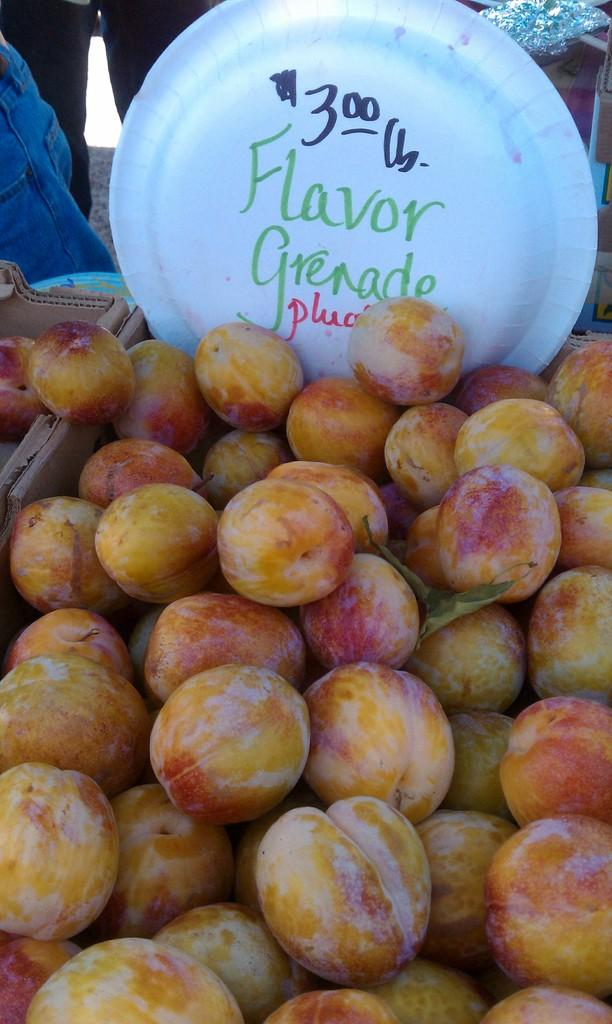What is inside the boxes in the image? There are fruits in the boxes. What is on the white plate in the image? There is a white color plate with text on it. Can you describe anything about the person in the image? Legs of a person are visible in the background of the image. What type of payment is being made by the governor in the image? There is no governor or payment present in the image. What role does the porter play in the image? There is no porter present in the image. 